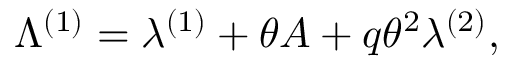Convert formula to latex. <formula><loc_0><loc_0><loc_500><loc_500>\Lambda ^ { ( 1 ) } = \lambda ^ { ( 1 ) } + \theta A + q \theta ^ { 2 } \lambda ^ { ( 2 ) } ,</formula> 